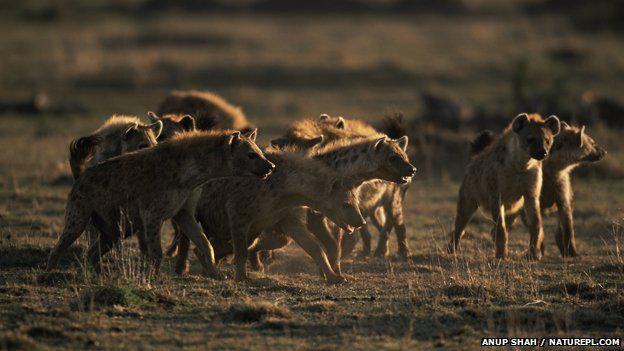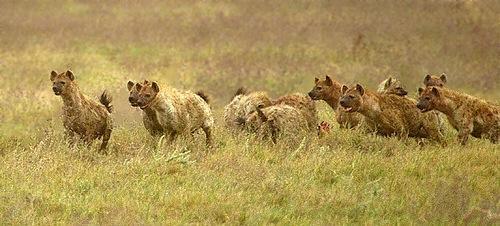The first image is the image on the left, the second image is the image on the right. Analyze the images presented: Is the assertion "There are at most 4 hyenas in one of the images." valid? Answer yes or no. No. The first image is the image on the left, the second image is the image on the right. Examine the images to the left and right. Is the description "A lion is with a group of hyenas in at least one of the images." accurate? Answer yes or no. No. The first image is the image on the left, the second image is the image on the right. Evaluate the accuracy of this statement regarding the images: "One image contains at least one lion.". Is it true? Answer yes or no. No. 